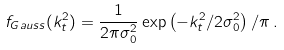Convert formula to latex. <formula><loc_0><loc_0><loc_500><loc_500>f _ { G a u s s } ( k _ { t } ^ { 2 } ) = \frac { 1 } { 2 \pi \sigma _ { 0 } ^ { 2 } } \exp \left ( - k _ { t } ^ { 2 } / 2 \sigma _ { 0 } ^ { 2 } \right ) / \pi \, . \\ \,</formula> 